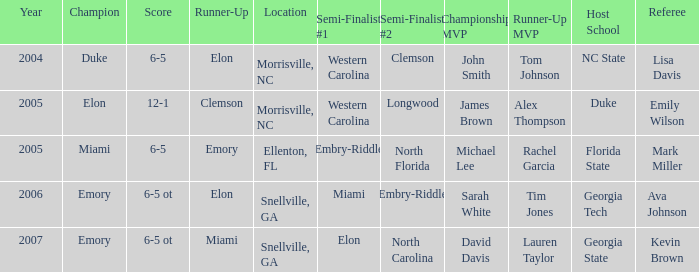List all the competitors who came in behind embry-riddle when they secured the first semi-finalist spot. Emory. 